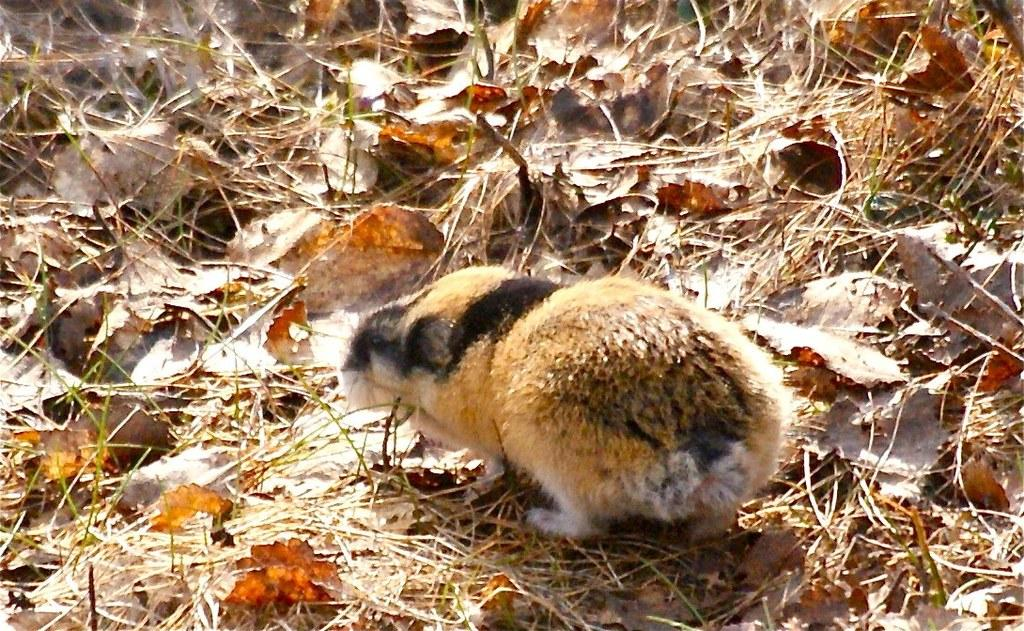What type of surface is the animal on in the image? The animal is on the grass in the image. What other elements can be seen in the image besides the animal? There are dried leaves in the image. Where is the sea located in the image? There is no sea present in the image. What type of bread can be seen in the image? There is no bread present in the image. 